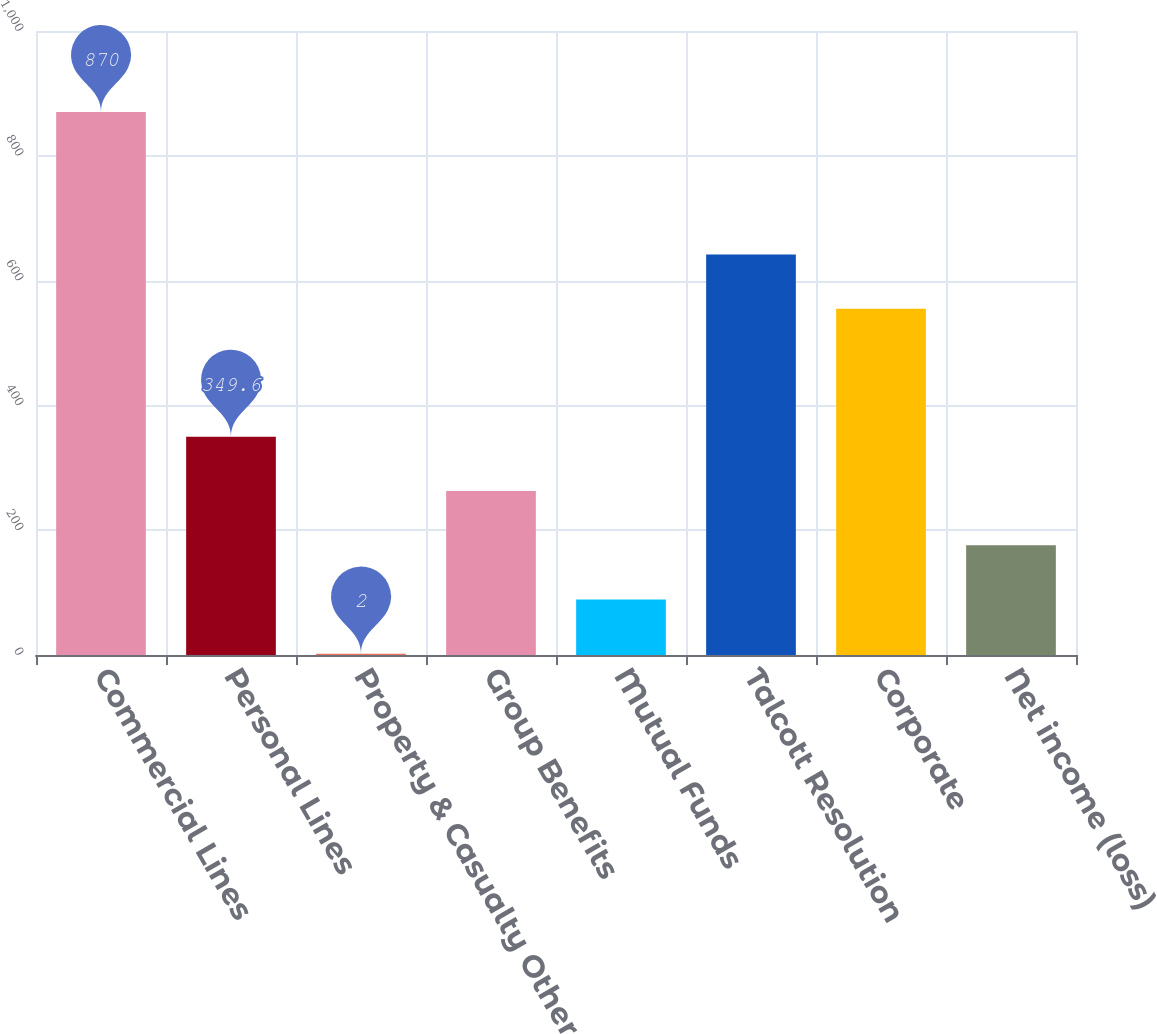Convert chart. <chart><loc_0><loc_0><loc_500><loc_500><bar_chart><fcel>Commercial Lines<fcel>Personal Lines<fcel>Property & Casualty Other<fcel>Group Benefits<fcel>Mutual Funds<fcel>Talcott Resolution<fcel>Corporate<fcel>Net income (loss)<nl><fcel>870<fcel>349.6<fcel>2<fcel>262.8<fcel>88.8<fcel>641.8<fcel>555<fcel>176<nl></chart> 